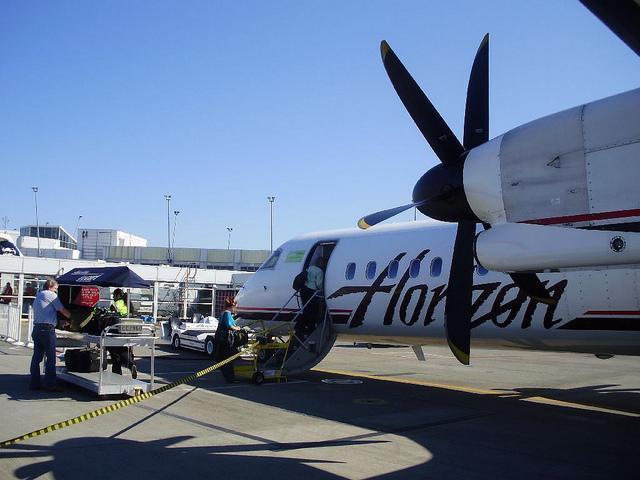How many blades does the propeller have?
Give a very brief answer. 6. How many propellers are there?
Give a very brief answer. 1. How many stripes on each blade of the propeller?
Give a very brief answer. 1. How many people are there?
Give a very brief answer. 1. How many white computer mice are in the image?
Give a very brief answer. 0. 